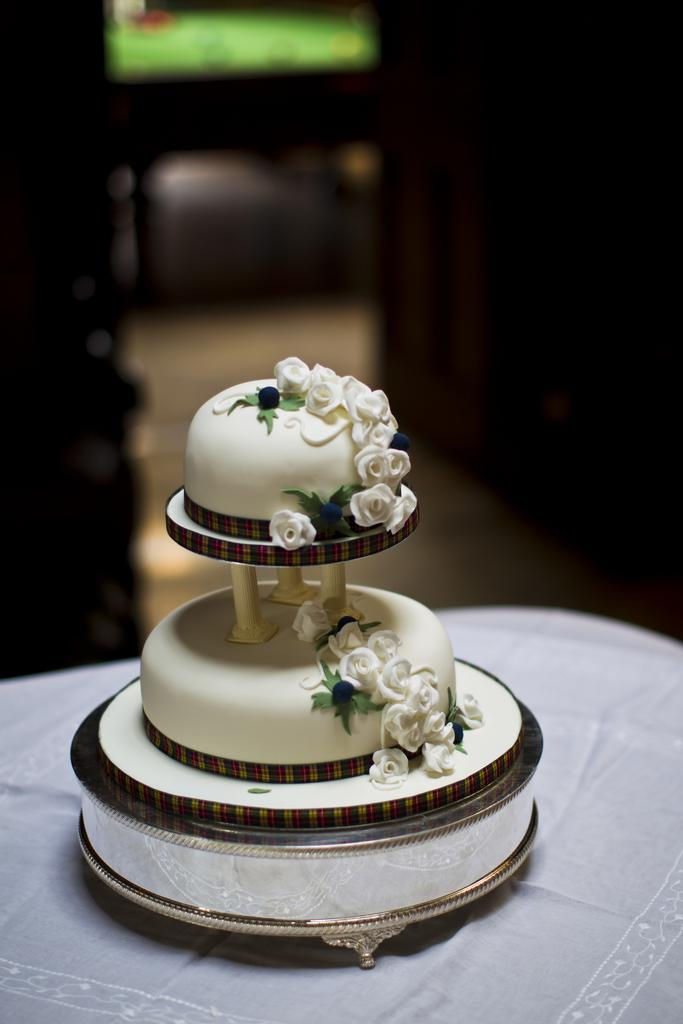What is the main subject of the image? There is a cake in the image. Can you describe the background of the image? The background of the image is blurry. Do the snails in the image express regret for not attending the cake-cutting ceremony? There are no snails present in the image, so it is not possible to determine their feelings or actions. 